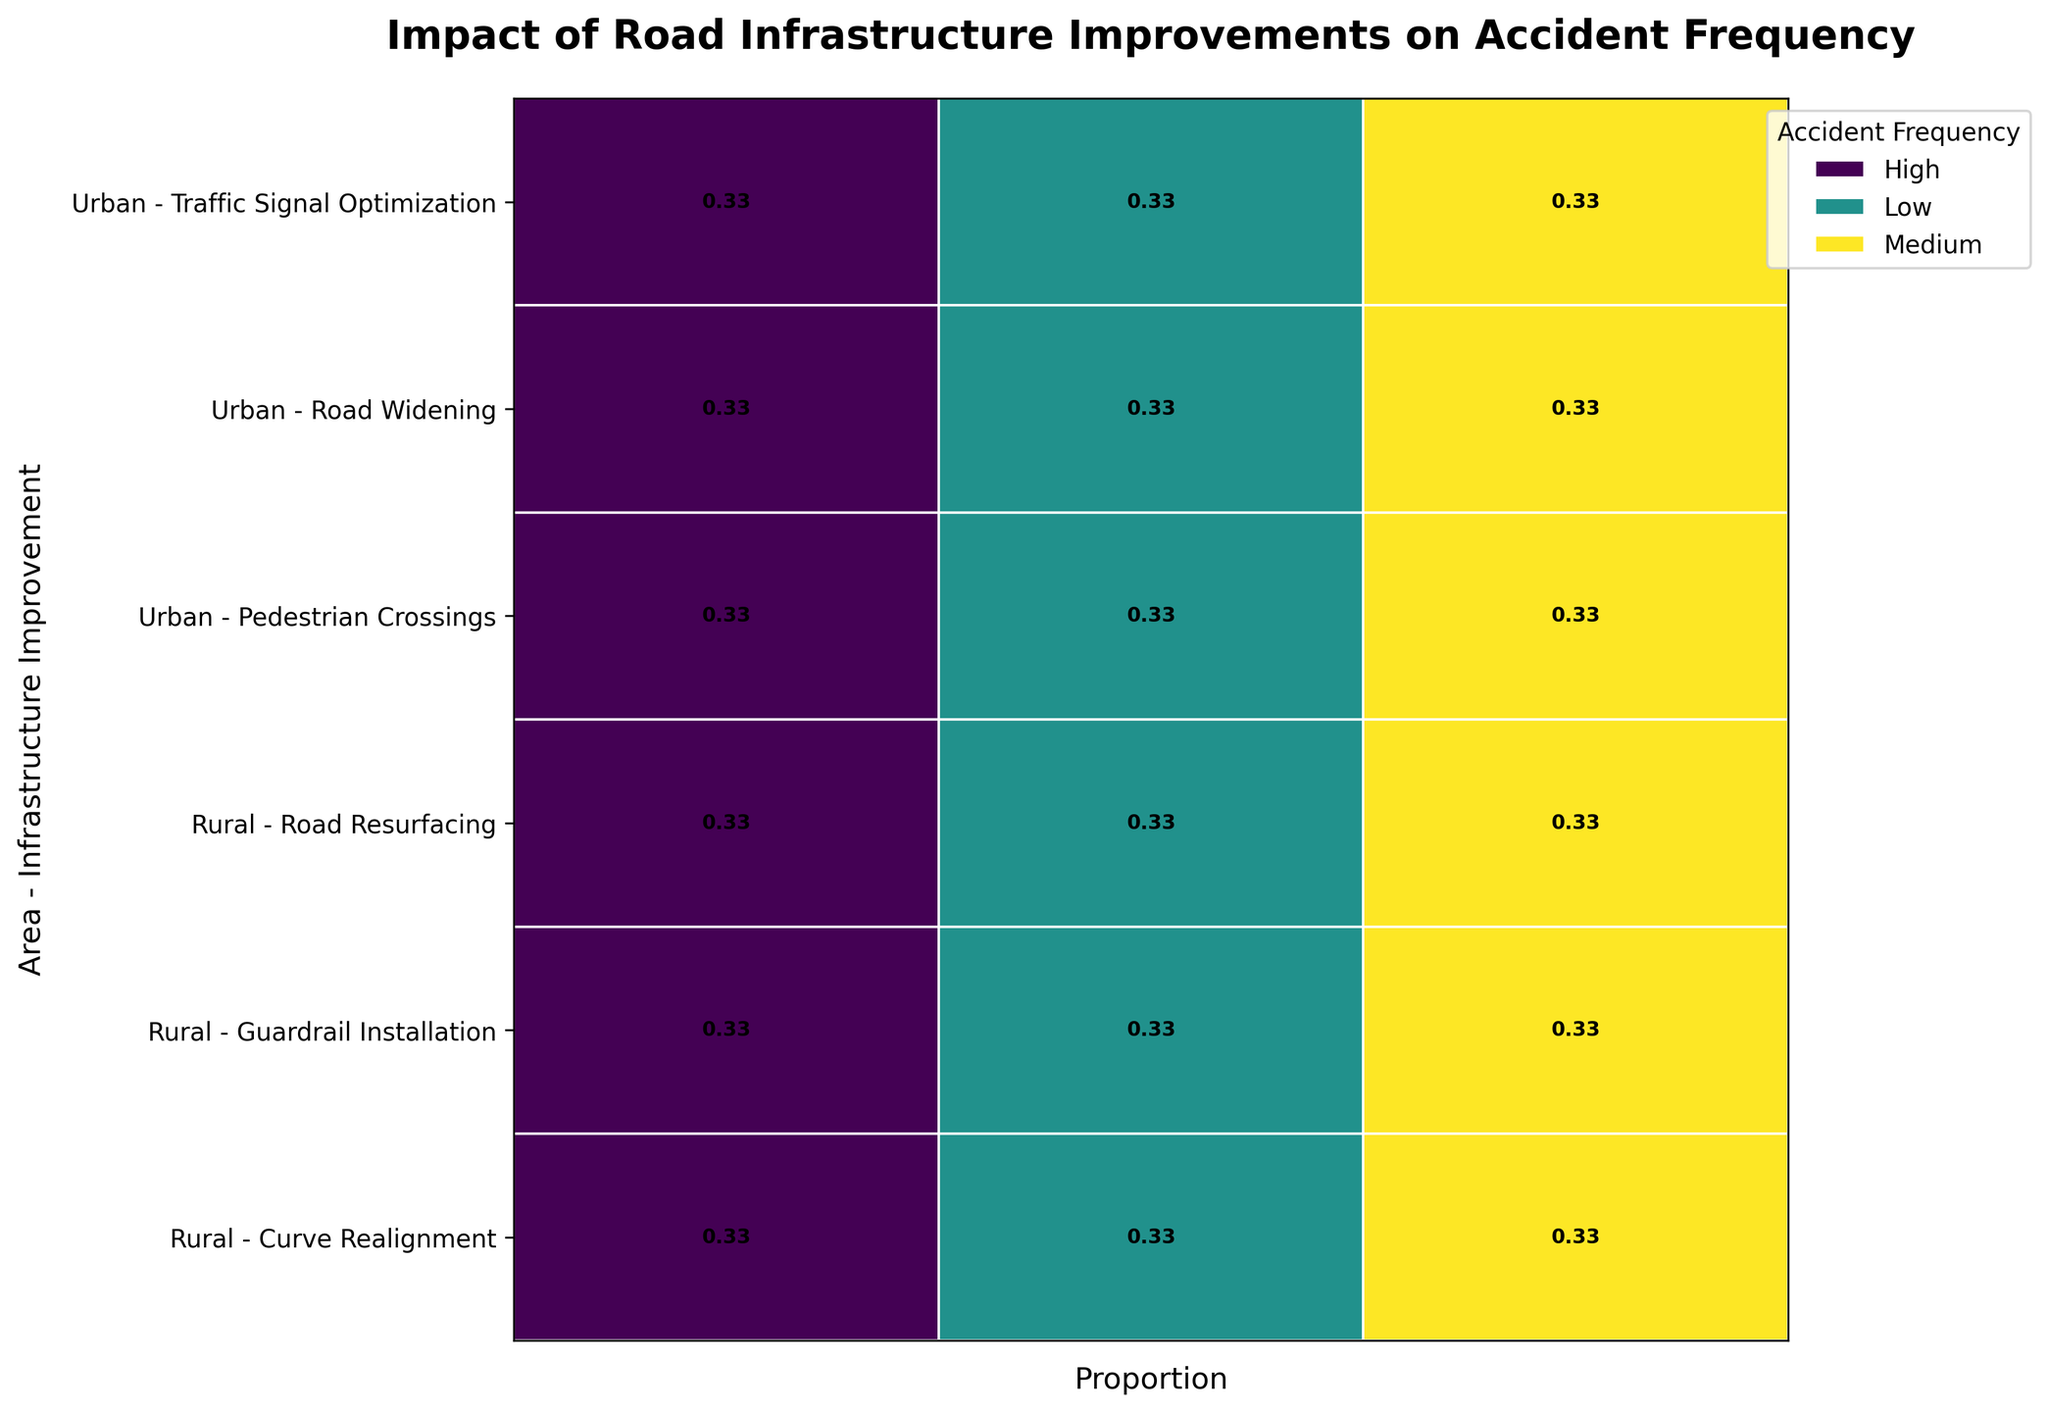What's the title of the figure? The title is usually placed at the top of the chart. In this figure, it is located at the top-center and reads "Impact of Road Infrastructure Improvements on Accident Frequency".
Answer: Impact of Road Infrastructure Improvements on Accident Frequency How are Urban areas visually distinguished on the plot? The plot categorizes Urban areas by specific types of infrastructure improvements and stacks them in a distinct section. They are usually labeled on one side of the plot and grouped together based on the provided data.
Answer: By selected infrastructure improvements like Road Widening, Traffic Signal Optimization, and Pedestrian Crossings Which area has more variety in the types of infrastructure improvements shown, Urban or Rural? To determine this, count the distinct types of infrastructure improvements listed under each area label. Urban has Road Widening, Traffic Signal Optimization, and Pedestrian Crossings. Rural has Road Resurfacing, Guardrail Installation, and Curve Realignment.
Answer: Both Urban and Rural have an equal variety of 3 types each What's the most common accident frequency level for Urban areas with Road Widening? Review the proportions of accident frequencies (Low, Medium, High) for Urban - Road Widening. The width of each section represents the proportion, and the widest section represents the most common level.
Answer: Medium Which infrastructure improvement in Rural areas shows the highest proportion of Low accident frequency? Look for the Rural area improvements and identify the rectangle representing Low accident frequency. Compare its widths across different infrastructure types to identify the widest one.
Answer: Guardrail Installation How does the proportion of High accident frequency compare between Urban - Traffic Signal Optimization and Rural - Curve Realignment? Compare the widths of the rectangles for High accident frequency in those two categories. By observing their relative sizes, one can determine which has a higher or lower proportion.
Answer: Urban - Traffic Signal Optimization is higher What is the proportion of Low accident frequency for Rural - Road Resurfacing? Find the Rural - Road Resurfacing row and measure the width of the rectangle for Low accident frequency. The width is typically marked with a specific value or can be visually estimated from the plot.
Answer: Approximately 0.2 Which infrastructure improvement in Urban areas shows the lowest proportion of Medium accident frequency? Inspect all Urban area improvements and compare the widths of the Medium accident frequency rectangles. Identify which one has the narrowest or smallest width.
Answer: Pedestrian Crossings Are there any infrastructure improvements in either Urban or Rural areas that have an equal proportion of all accident frequency levels? Examine each rectangle in a specific row and see if they share the same width or value, indicating equal proportions across Low, Medium, and High levels.
Answer: No In Rural areas, which improvement has the highest combined proportion of Low and Medium accident frequencies? Sum the widths of the Low and Medium rectangles for each Rural improvement. Compare these sums to determine which has the highest combined proportion of Low and Medium frequencies.
Answer: Guardrail Installation 